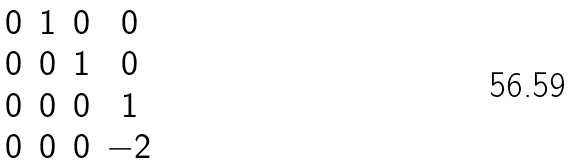<formula> <loc_0><loc_0><loc_500><loc_500>\begin{matrix} 0 & 1 & 0 & 0 \\ 0 & 0 & 1 & 0 \\ 0 & 0 & 0 & 1 \\ 0 & 0 & 0 & - 2 \end{matrix}</formula> 